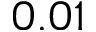Convert formula to latex. <formula><loc_0><loc_0><loc_500><loc_500>0 . 0 1</formula> 